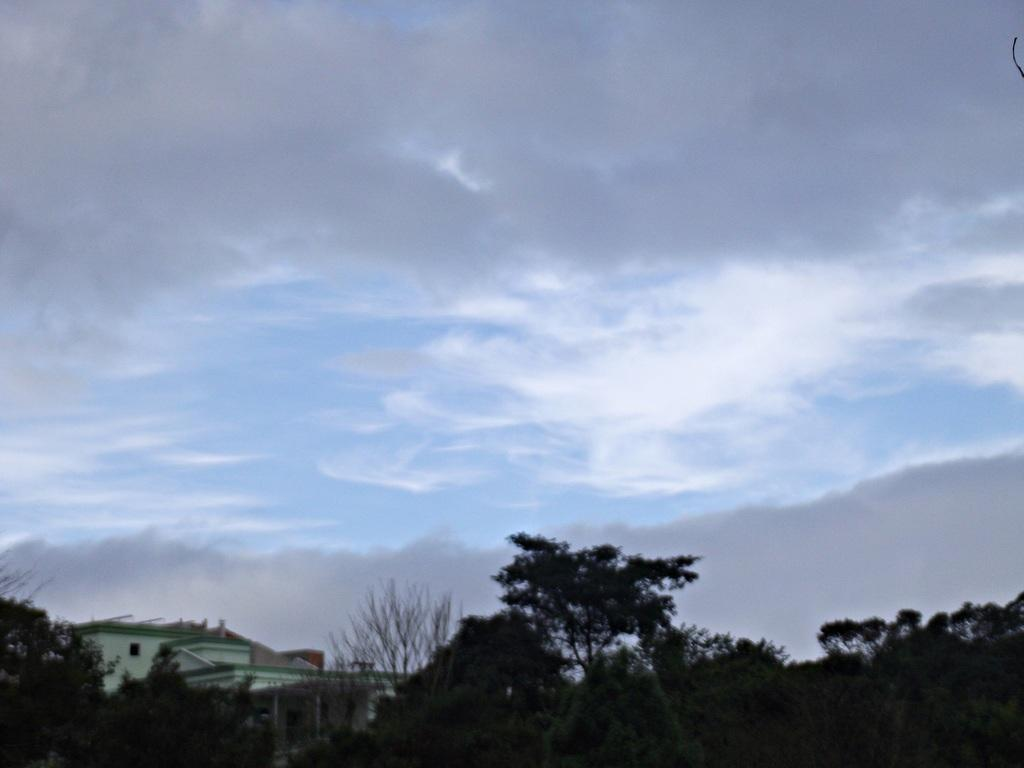What type of vegetation can be seen in the image? There are trees in the image. What type of structures are present in the image? There are buildings in the image. What is visible in the sky at the top of the image? There are clouds in the sky at the top of the image. What type of jeans can be seen hanging on the trees in the image? There are no jeans present in the image; it features trees and buildings. What type of carriage is visible being pulled by the clouds in the image? There is no carriage present in the image, and the clouds are not pulling anything. 